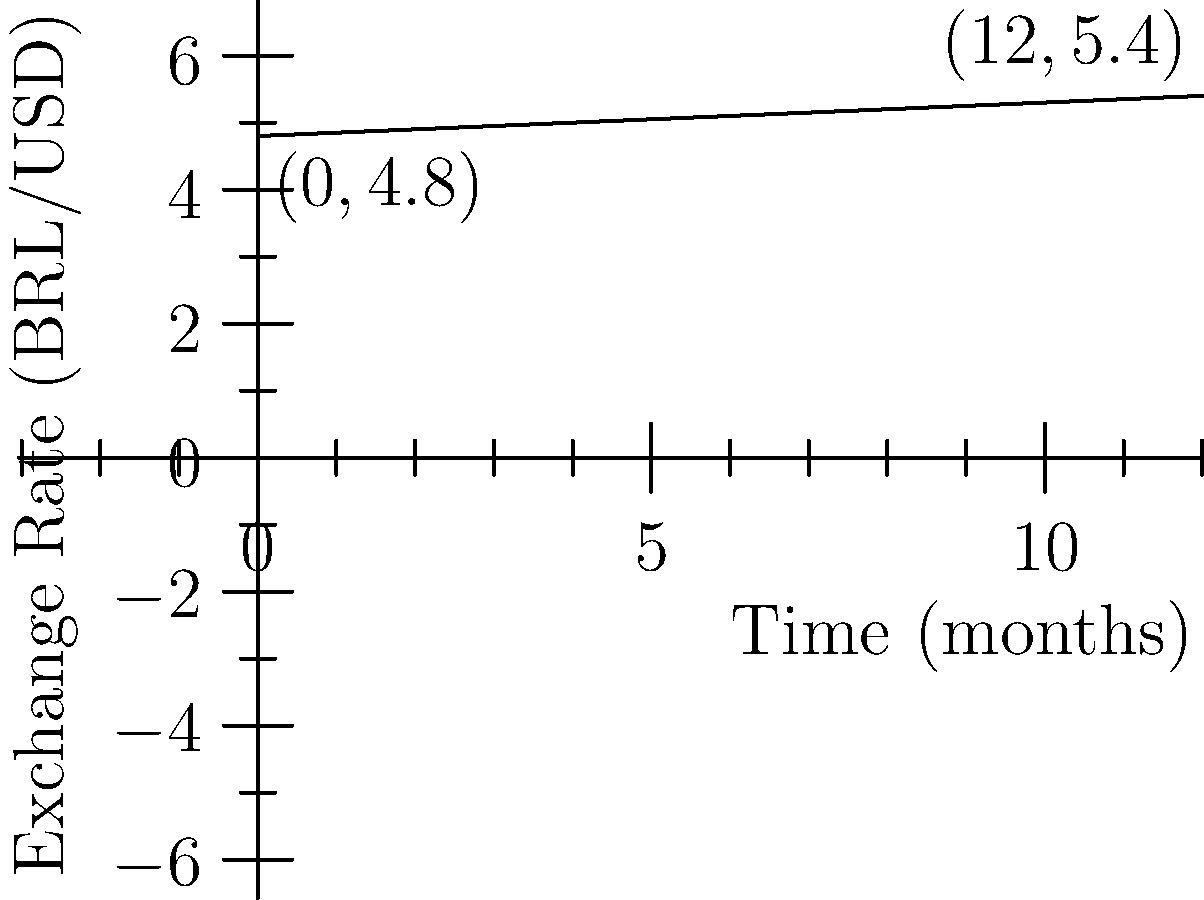In your analysis of the Brazilian Real (BRL) to US Dollar (USD) exchange rate, you've plotted a linear trend over a 12-month period as shown in the graph. If this trend continues, what will be the exchange rate after 18 months, and how much will the BRL have depreciated against the USD in percentage terms from the start of this period? Let's approach this step-by-step:

1) First, we need to find the equation of the line. We can do this using the point-slope form:
   $y - y_1 = m(x - x_1)$

2) We can see two points on the line: $(0, 4.8)$ and $(12, 5.4)$

3) Calculate the slope:
   $m = \frac{y_2 - y_1}{x_2 - x_1} = \frac{5.4 - 4.8}{12 - 0} = \frac{0.6}{12} = 0.05$

4) Now we can form the equation using the point $(0, 4.8)$:
   $y - 4.8 = 0.05(x - 0)$
   $y = 0.05x + 4.8$

5) To find the exchange rate after 18 months, substitute $x = 18$:
   $y = 0.05(18) + 4.8 = 0.9 + 4.8 = 5.7$

6) To calculate the depreciation:
   Initial rate: 4.8 BRL/USD
   Rate after 18 months: 5.7 BRL/USD
   
   Percentage change = $\frac{\text{New Value} - \text{Original Value}}{\text{Original Value}} \times 100\%$
   $= \frac{5.7 - 4.8}{4.8} \times 100\% = \frac{0.9}{4.8} \times 100\% = 18.75\%$
Answer: 5.7 BRL/USD; 18.75% depreciation 